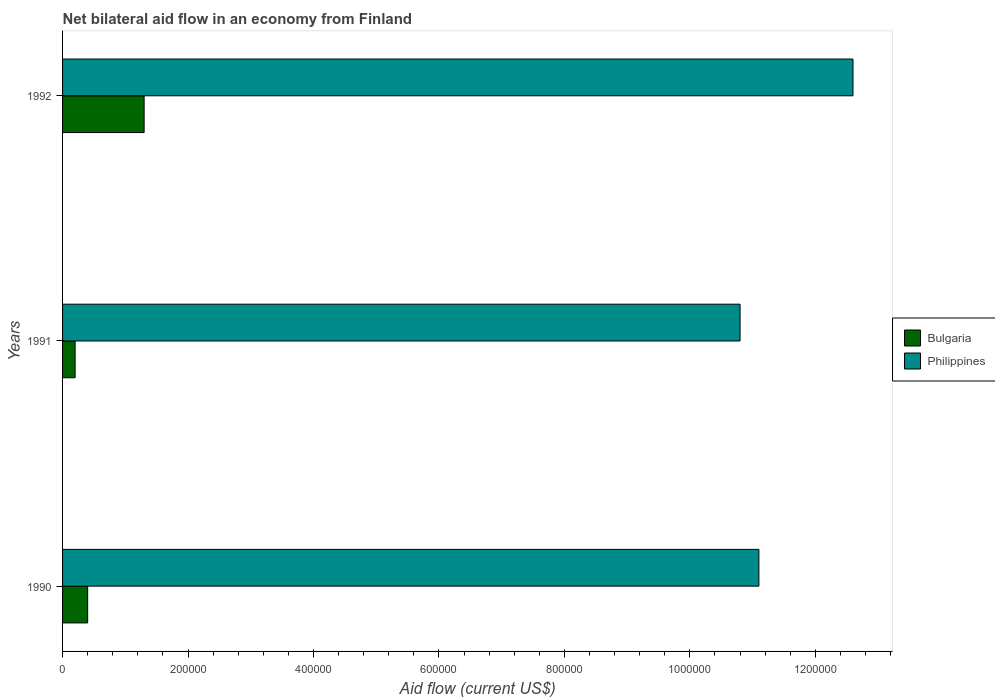How many different coloured bars are there?
Provide a succinct answer. 2. What is the label of the 2nd group of bars from the top?
Provide a succinct answer. 1991. In how many cases, is the number of bars for a given year not equal to the number of legend labels?
Offer a terse response. 0. Across all years, what is the maximum net bilateral aid flow in Bulgaria?
Your answer should be very brief. 1.30e+05. In which year was the net bilateral aid flow in Philippines maximum?
Keep it short and to the point. 1992. What is the total net bilateral aid flow in Philippines in the graph?
Give a very brief answer. 3.45e+06. What is the difference between the net bilateral aid flow in Bulgaria in 1990 and that in 1992?
Provide a succinct answer. -9.00e+04. What is the difference between the net bilateral aid flow in Philippines in 1990 and the net bilateral aid flow in Bulgaria in 1991?
Offer a terse response. 1.09e+06. What is the average net bilateral aid flow in Philippines per year?
Your answer should be very brief. 1.15e+06. In the year 1990, what is the difference between the net bilateral aid flow in Bulgaria and net bilateral aid flow in Philippines?
Offer a very short reply. -1.07e+06. In how many years, is the net bilateral aid flow in Philippines greater than 240000 US$?
Offer a very short reply. 3. What is the ratio of the net bilateral aid flow in Philippines in 1990 to that in 1992?
Your answer should be very brief. 0.88. Is the net bilateral aid flow in Bulgaria in 1990 less than that in 1992?
Ensure brevity in your answer.  Yes. What is the difference between the highest and the lowest net bilateral aid flow in Bulgaria?
Your response must be concise. 1.10e+05. Is the sum of the net bilateral aid flow in Philippines in 1991 and 1992 greater than the maximum net bilateral aid flow in Bulgaria across all years?
Offer a terse response. Yes. What does the 2nd bar from the bottom in 1992 represents?
Ensure brevity in your answer.  Philippines. Where does the legend appear in the graph?
Provide a succinct answer. Center right. What is the title of the graph?
Make the answer very short. Net bilateral aid flow in an economy from Finland. What is the label or title of the X-axis?
Offer a very short reply. Aid flow (current US$). What is the label or title of the Y-axis?
Give a very brief answer. Years. What is the Aid flow (current US$) in Philippines in 1990?
Give a very brief answer. 1.11e+06. What is the Aid flow (current US$) in Bulgaria in 1991?
Provide a short and direct response. 2.00e+04. What is the Aid flow (current US$) of Philippines in 1991?
Provide a succinct answer. 1.08e+06. What is the Aid flow (current US$) in Philippines in 1992?
Offer a terse response. 1.26e+06. Across all years, what is the maximum Aid flow (current US$) of Philippines?
Your answer should be very brief. 1.26e+06. Across all years, what is the minimum Aid flow (current US$) of Bulgaria?
Make the answer very short. 2.00e+04. Across all years, what is the minimum Aid flow (current US$) of Philippines?
Give a very brief answer. 1.08e+06. What is the total Aid flow (current US$) in Philippines in the graph?
Ensure brevity in your answer.  3.45e+06. What is the difference between the Aid flow (current US$) in Bulgaria in 1990 and that in 1991?
Ensure brevity in your answer.  2.00e+04. What is the difference between the Aid flow (current US$) of Philippines in 1990 and that in 1992?
Offer a terse response. -1.50e+05. What is the difference between the Aid flow (current US$) in Bulgaria in 1990 and the Aid flow (current US$) in Philippines in 1991?
Offer a very short reply. -1.04e+06. What is the difference between the Aid flow (current US$) in Bulgaria in 1990 and the Aid flow (current US$) in Philippines in 1992?
Offer a very short reply. -1.22e+06. What is the difference between the Aid flow (current US$) in Bulgaria in 1991 and the Aid flow (current US$) in Philippines in 1992?
Provide a succinct answer. -1.24e+06. What is the average Aid flow (current US$) in Bulgaria per year?
Offer a terse response. 6.33e+04. What is the average Aid flow (current US$) in Philippines per year?
Offer a terse response. 1.15e+06. In the year 1990, what is the difference between the Aid flow (current US$) of Bulgaria and Aid flow (current US$) of Philippines?
Offer a very short reply. -1.07e+06. In the year 1991, what is the difference between the Aid flow (current US$) in Bulgaria and Aid flow (current US$) in Philippines?
Your answer should be compact. -1.06e+06. In the year 1992, what is the difference between the Aid flow (current US$) in Bulgaria and Aid flow (current US$) in Philippines?
Offer a terse response. -1.13e+06. What is the ratio of the Aid flow (current US$) of Philippines in 1990 to that in 1991?
Offer a terse response. 1.03. What is the ratio of the Aid flow (current US$) in Bulgaria in 1990 to that in 1992?
Provide a short and direct response. 0.31. What is the ratio of the Aid flow (current US$) in Philippines in 1990 to that in 1992?
Make the answer very short. 0.88. What is the ratio of the Aid flow (current US$) of Bulgaria in 1991 to that in 1992?
Give a very brief answer. 0.15. What is the ratio of the Aid flow (current US$) in Philippines in 1991 to that in 1992?
Keep it short and to the point. 0.86. What is the difference between the highest and the second highest Aid flow (current US$) in Bulgaria?
Offer a terse response. 9.00e+04. What is the difference between the highest and the second highest Aid flow (current US$) in Philippines?
Offer a very short reply. 1.50e+05. What is the difference between the highest and the lowest Aid flow (current US$) of Bulgaria?
Ensure brevity in your answer.  1.10e+05. 